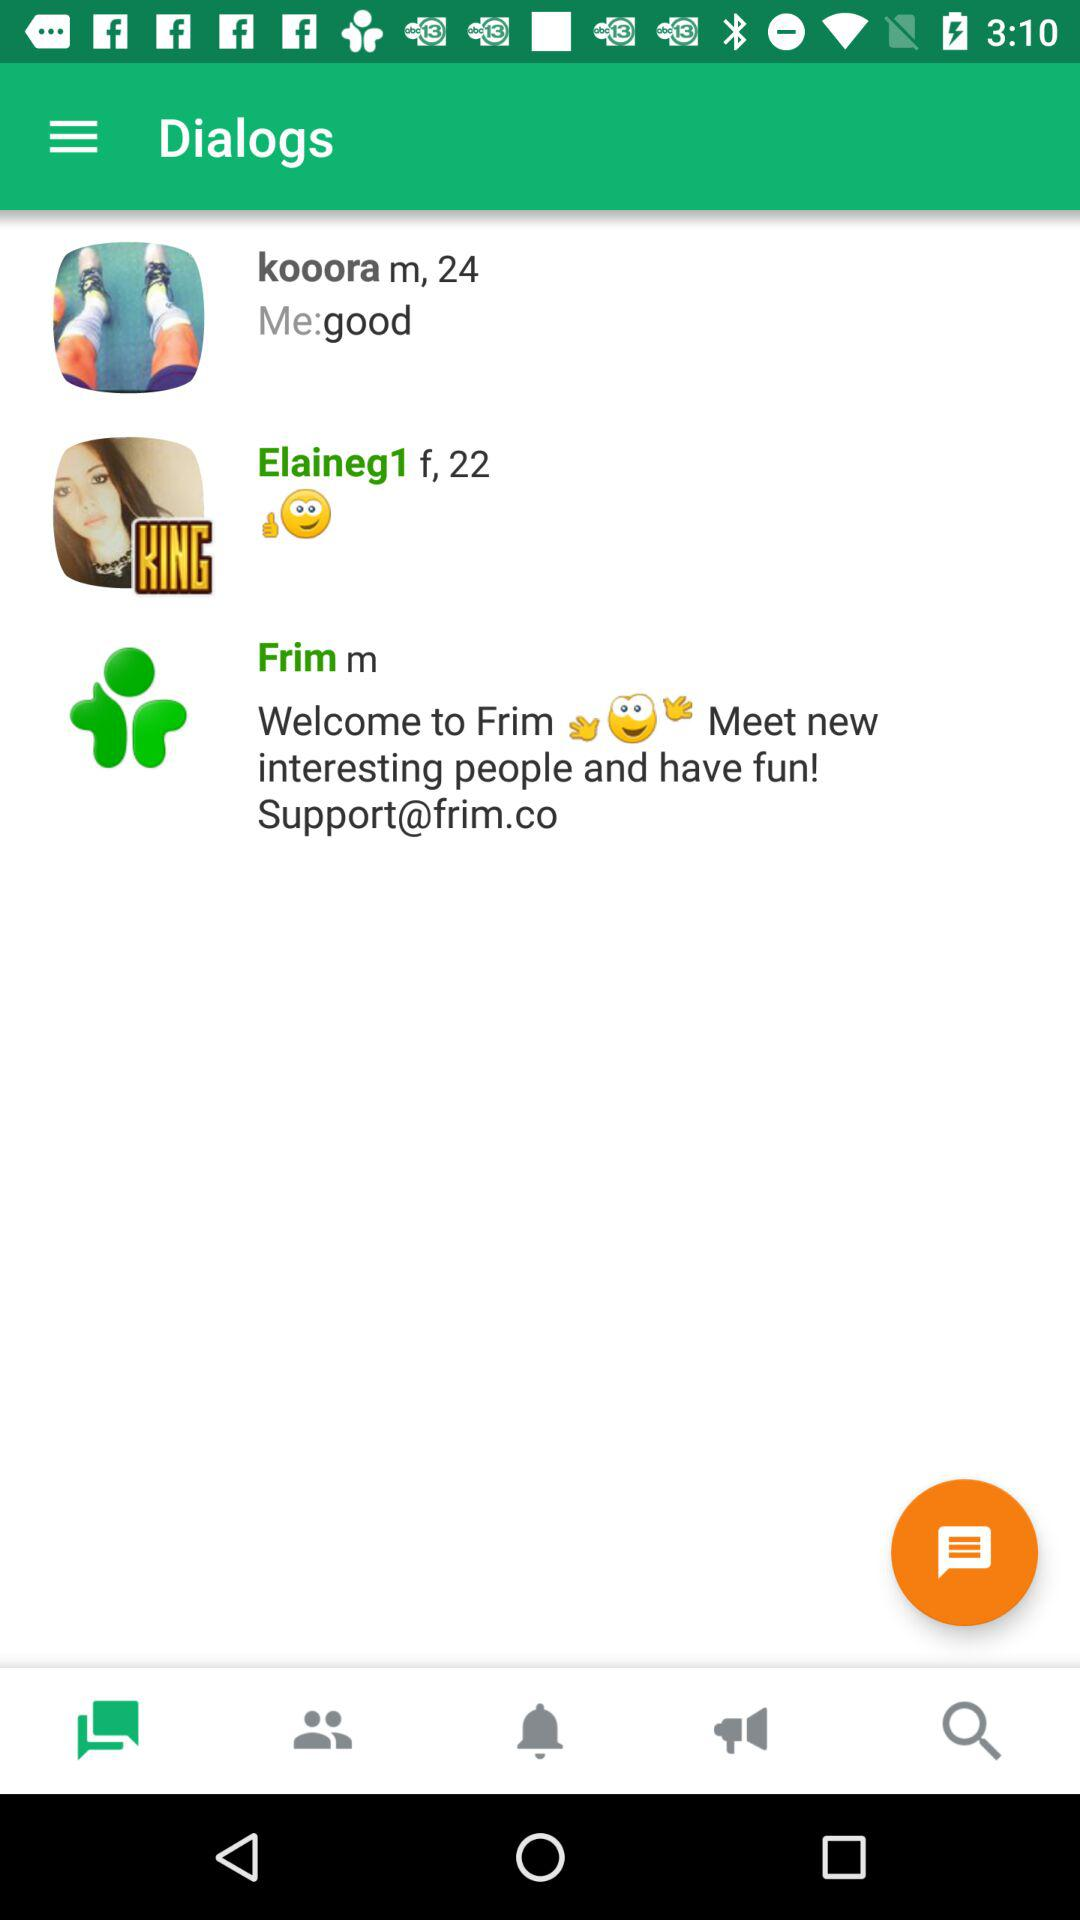What is the age of "Elaineg1"? The age of "Elaineg1" is 22 years. 